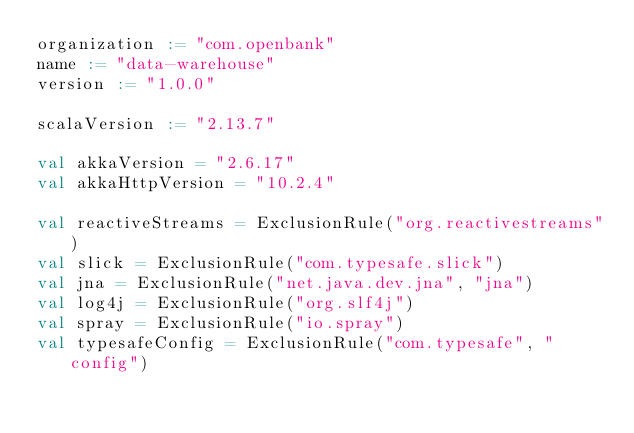Convert code to text. <code><loc_0><loc_0><loc_500><loc_500><_Scala_>organization := "com.openbank"
name := "data-warehouse"
version := "1.0.0"

scalaVersion := "2.13.7"

val akkaVersion = "2.6.17"
val akkaHttpVersion = "10.2.4"

val reactiveStreams = ExclusionRule("org.reactivestreams")
val slick = ExclusionRule("com.typesafe.slick")
val jna = ExclusionRule("net.java.dev.jna", "jna")
val log4j = ExclusionRule("org.slf4j")
val spray = ExclusionRule("io.spray")
val typesafeConfig = ExclusionRule("com.typesafe", "config")</code> 